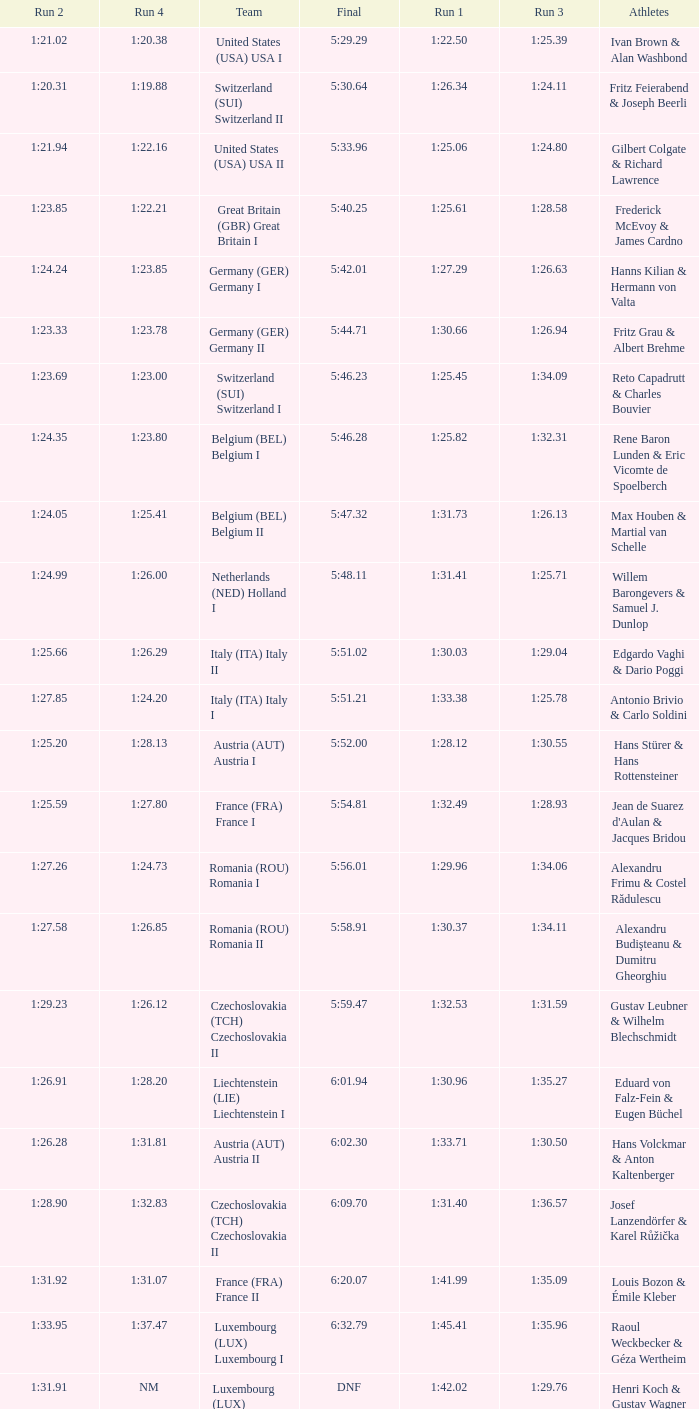Which Final has a Run 2 of 1:27.58? 5:58.91. 